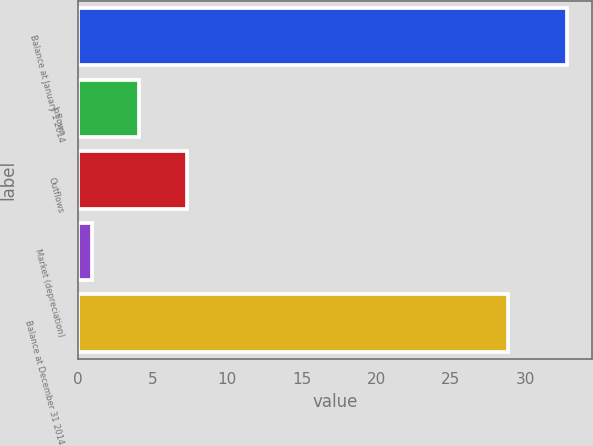<chart> <loc_0><loc_0><loc_500><loc_500><bar_chart><fcel>Balance at January 1 2014<fcel>Inflows<fcel>Outflows<fcel>Market (depreciation)<fcel>Balance at December 31 2014<nl><fcel>32.8<fcel>4.09<fcel>7.28<fcel>0.9<fcel>28.8<nl></chart> 